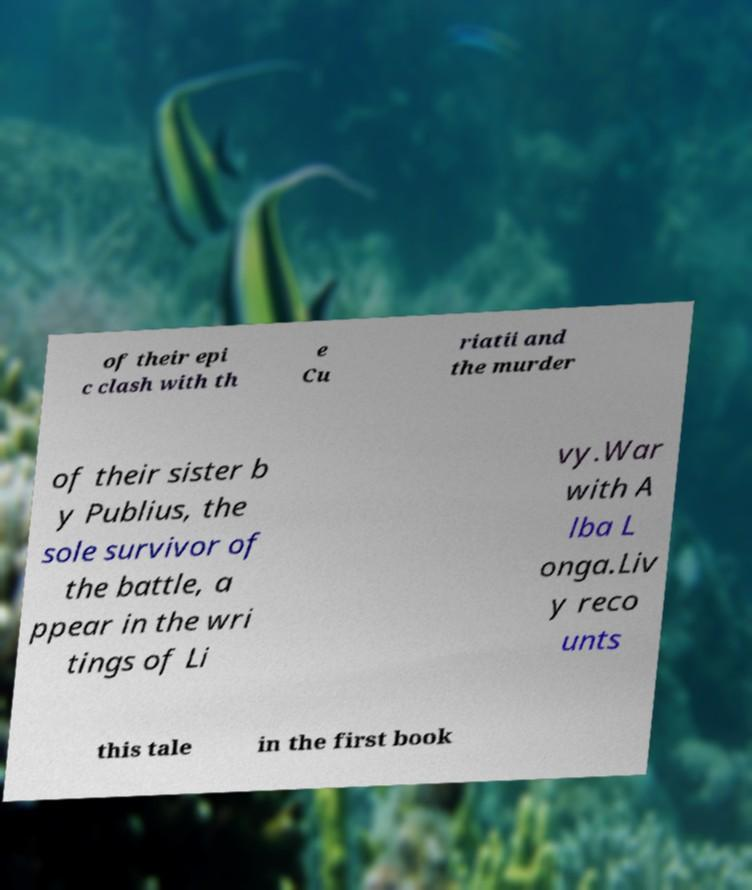For documentation purposes, I need the text within this image transcribed. Could you provide that? of their epi c clash with th e Cu riatii and the murder of their sister b y Publius, the sole survivor of the battle, a ppear in the wri tings of Li vy.War with A lba L onga.Liv y reco unts this tale in the first book 